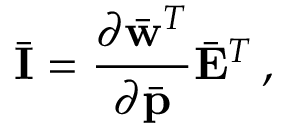<formula> <loc_0><loc_0><loc_500><loc_500>\bar { I } = \frac { \partial \bar { w } ^ { T } } { \partial \bar { p } } \bar { E } ^ { T } \, ,</formula> 